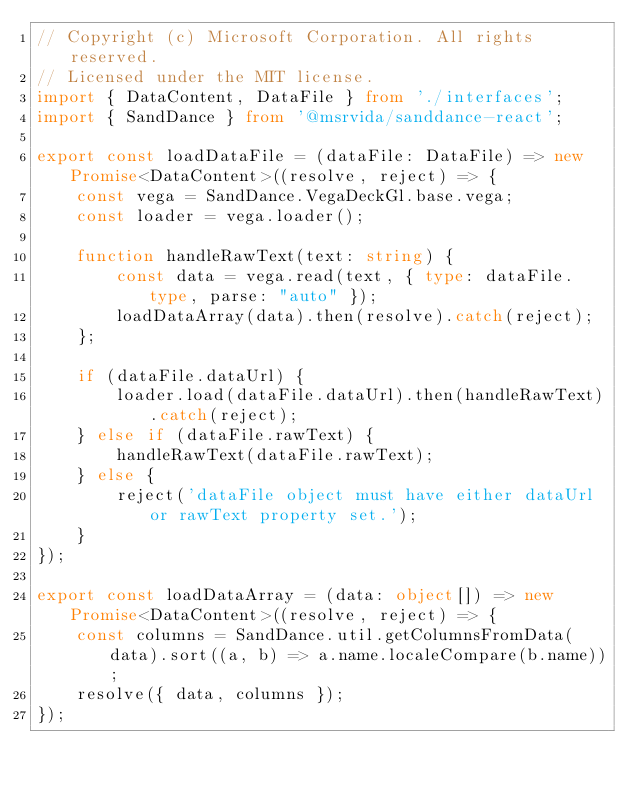Convert code to text. <code><loc_0><loc_0><loc_500><loc_500><_TypeScript_>// Copyright (c) Microsoft Corporation. All rights reserved.
// Licensed under the MIT license.
import { DataContent, DataFile } from './interfaces';
import { SandDance } from '@msrvida/sanddance-react';

export const loadDataFile = (dataFile: DataFile) => new Promise<DataContent>((resolve, reject) => {
    const vega = SandDance.VegaDeckGl.base.vega;
    const loader = vega.loader();

    function handleRawText(text: string) {
        const data = vega.read(text, { type: dataFile.type, parse: "auto" });
        loadDataArray(data).then(resolve).catch(reject);
    };

    if (dataFile.dataUrl) {
        loader.load(dataFile.dataUrl).then(handleRawText).catch(reject);
    } else if (dataFile.rawText) {
        handleRawText(dataFile.rawText);
    } else {
        reject('dataFile object must have either dataUrl or rawText property set.');
    }
});

export const loadDataArray = (data: object[]) => new Promise<DataContent>((resolve, reject) => {
    const columns = SandDance.util.getColumnsFromData(data).sort((a, b) => a.name.localeCompare(b.name));
    resolve({ data, columns });
});
</code> 